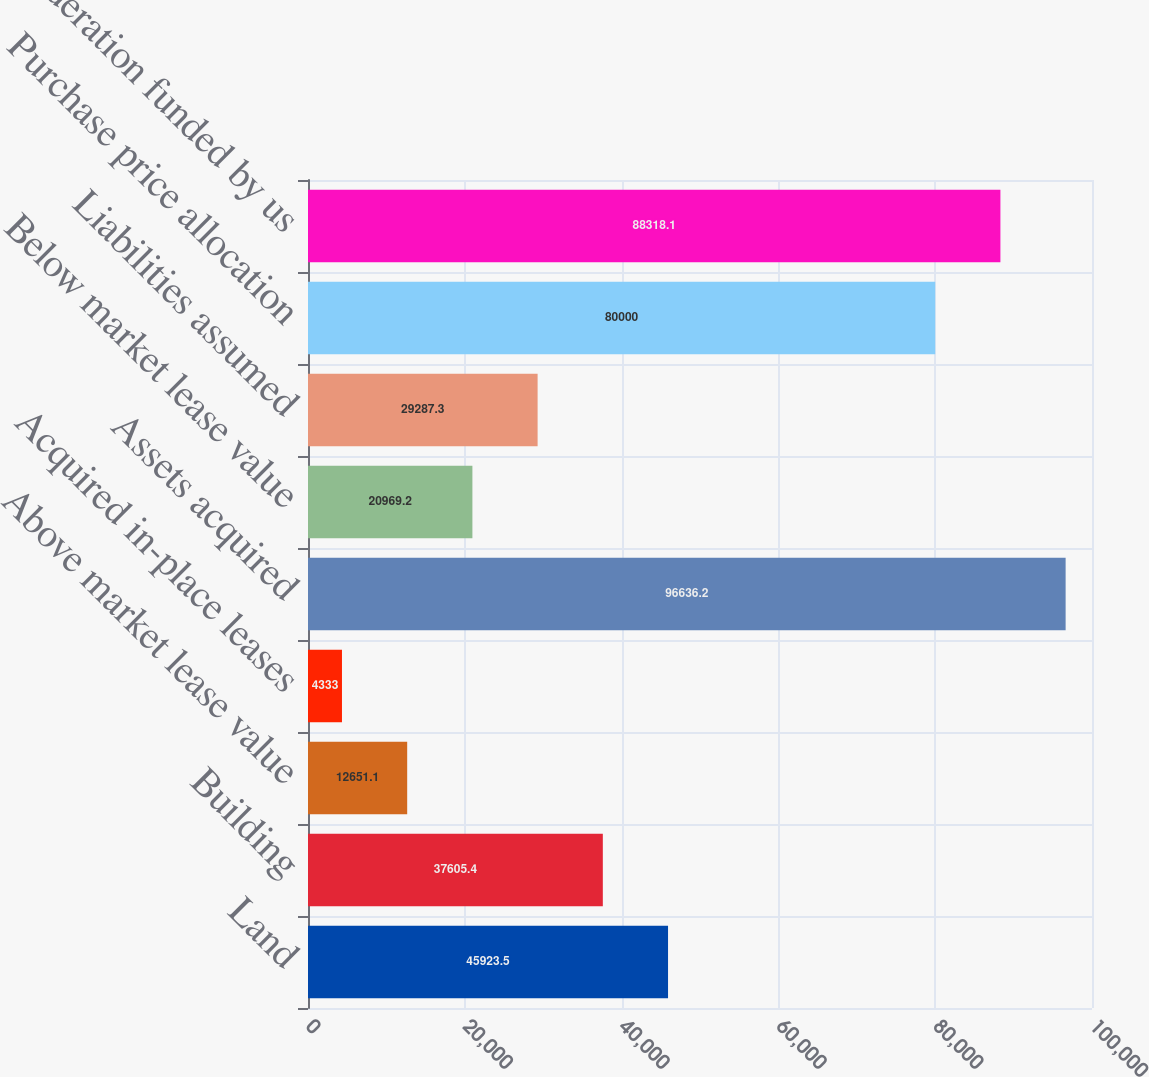<chart> <loc_0><loc_0><loc_500><loc_500><bar_chart><fcel>Land<fcel>Building<fcel>Above market lease value<fcel>Acquired in-place leases<fcel>Assets acquired<fcel>Below market lease value<fcel>Liabilities assumed<fcel>Purchase price allocation<fcel>Net consideration funded by us<nl><fcel>45923.5<fcel>37605.4<fcel>12651.1<fcel>4333<fcel>96636.2<fcel>20969.2<fcel>29287.3<fcel>80000<fcel>88318.1<nl></chart> 